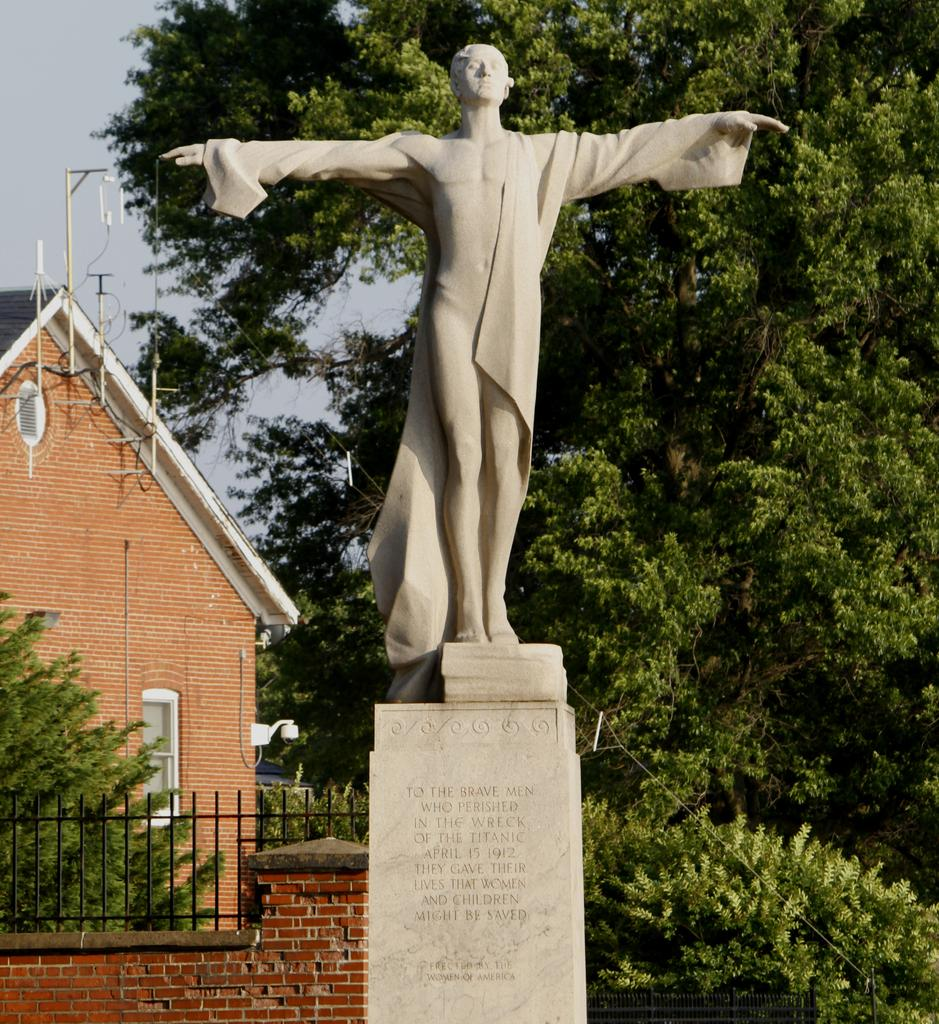What is the main subject of the image? There is a statue of a person in the image. Can you describe the statue's appearance? The statue is ash in color. Where is the statue located? The statue is on a concrete pillar. What can be seen in the background of the image? There is a railing, a wall, trees, a building, and the sky visible in the background of the image. What type of bell can be heard ringing in the image? There is no bell present in the image, and therefore no sound can be heard. Can you describe the brain of the person depicted in the statue? The image is of a statue, not a real person, so there is no brain to describe. 